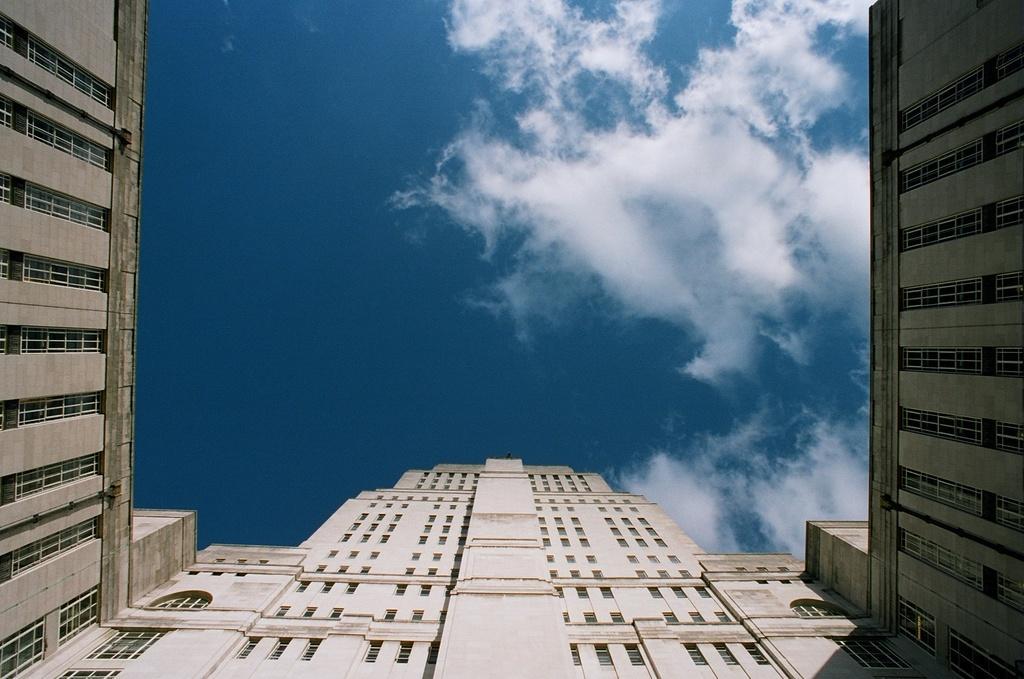Can you describe this image briefly? As we can see in the image there are buildings, windows, sky and clouds. 